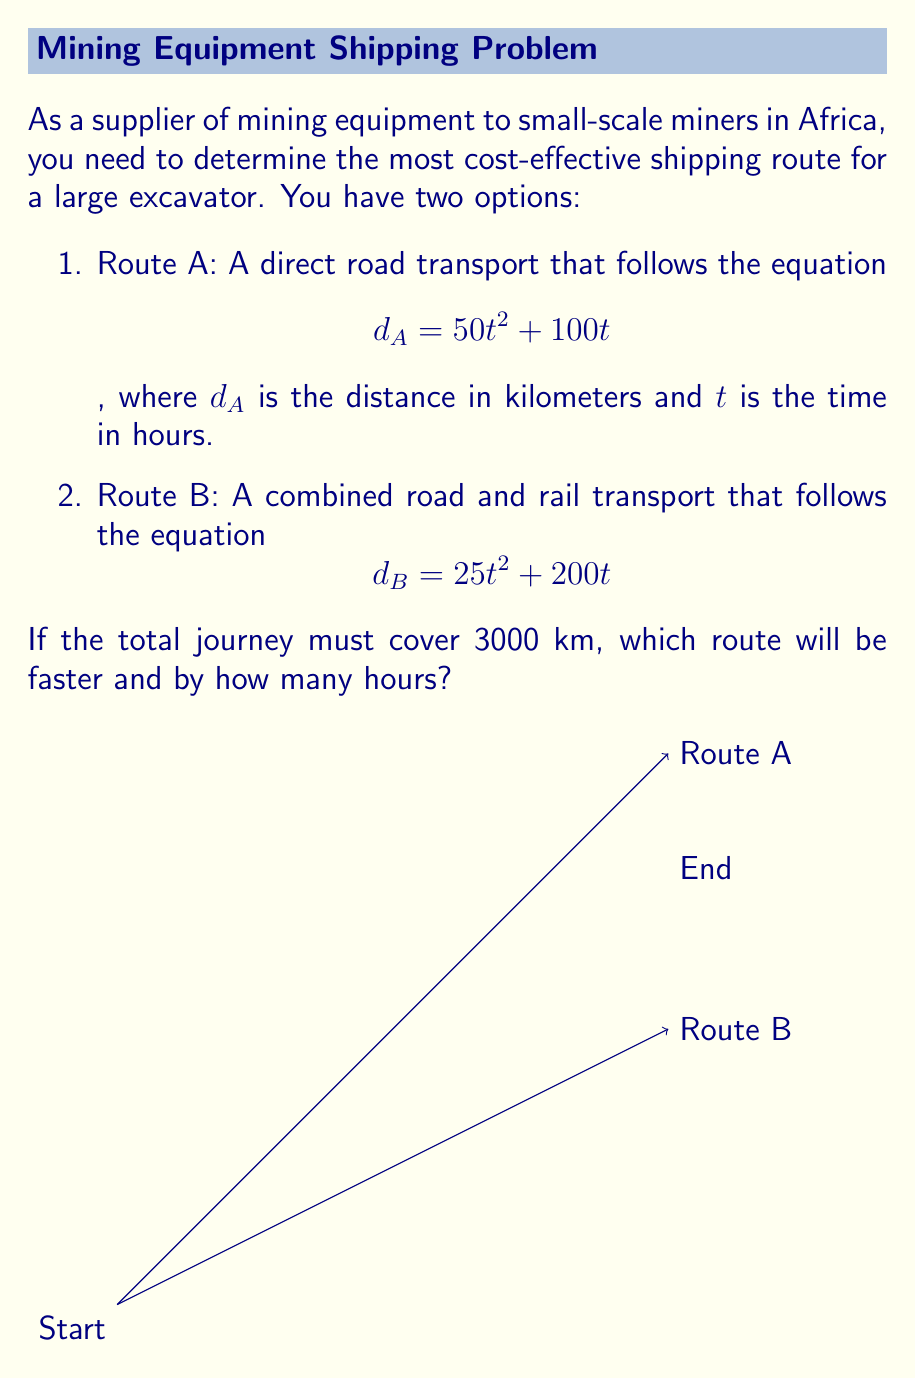What is the answer to this math problem? To solve this problem, we need to find the time taken for each route to cover 3000 km and then compare them.

1. For Route A:
   $$3000 = 50t^2 + 100t$$
   $$50t^2 + 100t - 3000 = 0$$
   
   This is a quadratic equation. We can solve it using the quadratic formula:
   $$t = \frac{-b \pm \sqrt{b^2 - 4ac}}{2a}$$
   
   Where $a=50$, $b=100$, and $c=-3000$
   
   $$t = \frac{-100 \pm \sqrt{100^2 - 4(50)(-3000)}}{2(50)}$$
   $$t = \frac{-100 \pm \sqrt{10000 + 600000}}{100}$$
   $$t = \frac{-100 \pm \sqrt{610000}}{100}$$
   $$t = \frac{-100 \pm 781.02}{100}$$
   
   We take the positive root:
   $$t_A = \frac{-100 + 781.02}{100} = 6.81$$ hours

2. For Route B:
   $$3000 = 25t^2 + 200t$$
   $$25t^2 + 200t - 3000 = 0$$
   
   Using the quadratic formula again:
   
   $$t = \frac{-200 \pm \sqrt{200^2 - 4(25)(-3000)}}{2(25)}$$
   $$t = \frac{-200 \pm \sqrt{40000 + 300000}}{50}$$
   $$t = \frac{-200 \pm \sqrt{340000}}{50}$$
   $$t = \frac{-200 \pm 583.10}{50}$$
   
   Taking the positive root:
   $$t_B = \frac{-200 + 583.10}{50} = 7.66$$ hours

3. Comparing the times:
   Route A takes 6.81 hours
   Route B takes 7.66 hours
   
   The difference is:
   $$7.66 - 6.81 = 0.85$$ hours
Answer: Route A is faster by 0.85 hours. 